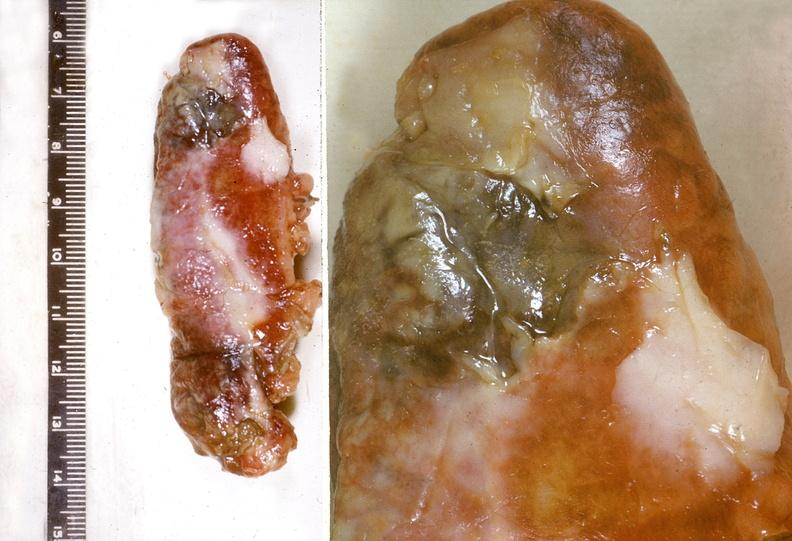what does this image show?
Answer the question using a single word or phrase. Appendix 